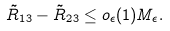Convert formula to latex. <formula><loc_0><loc_0><loc_500><loc_500>\tilde { R } _ { 1 3 } - \tilde { R } _ { 2 3 } \leq o _ { \epsilon } ( 1 ) M _ { \epsilon } .</formula> 